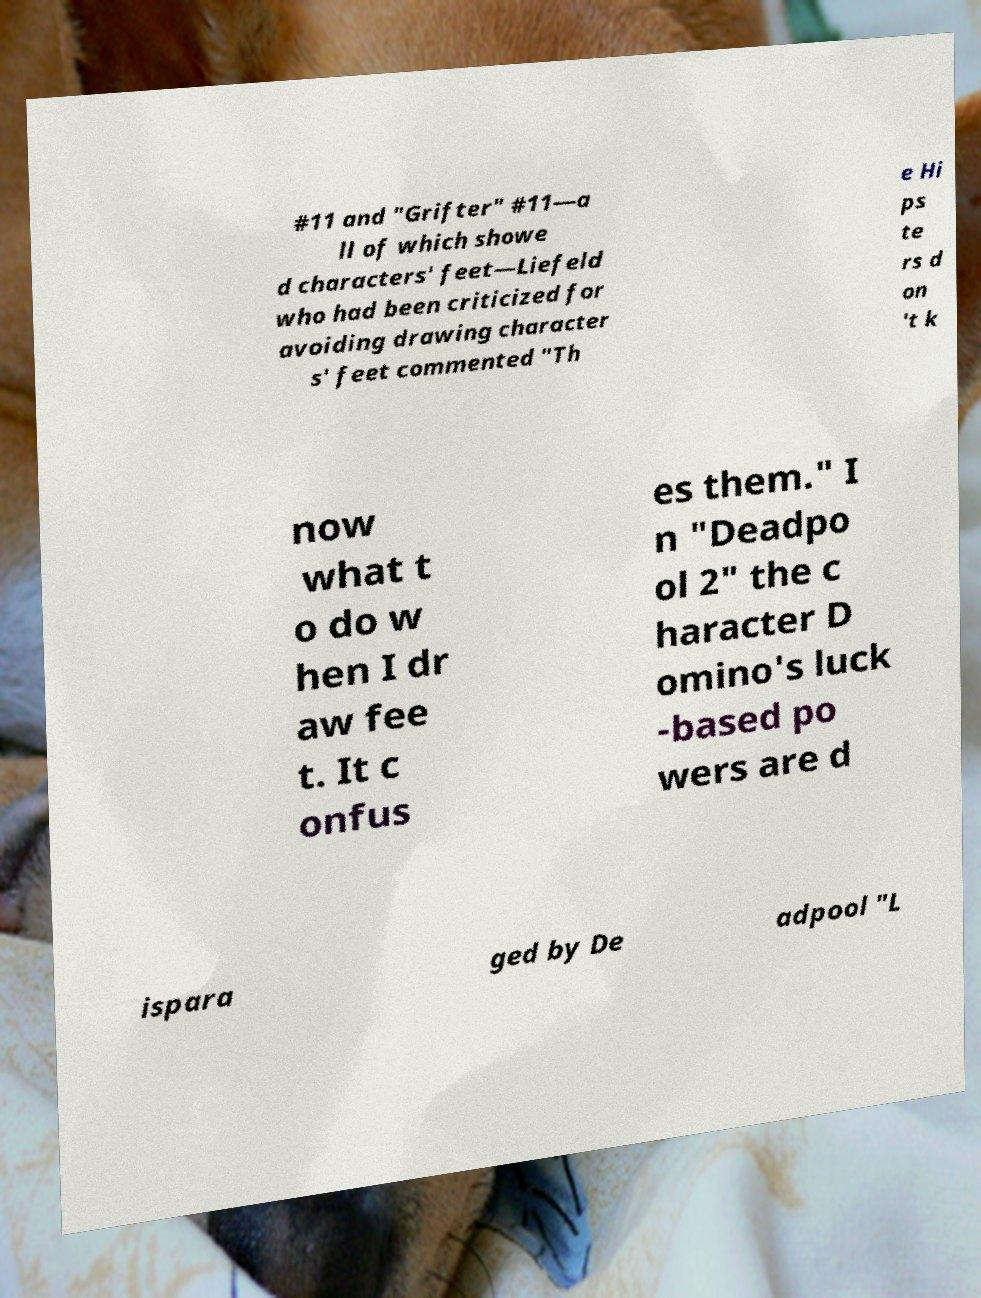Please identify and transcribe the text found in this image. #11 and "Grifter" #11—a ll of which showe d characters' feet—Liefeld who had been criticized for avoiding drawing character s' feet commented "Th e Hi ps te rs d on 't k now what t o do w hen I dr aw fee t. It c onfus es them." I n "Deadpo ol 2" the c haracter D omino's luck -based po wers are d ispara ged by De adpool "L 